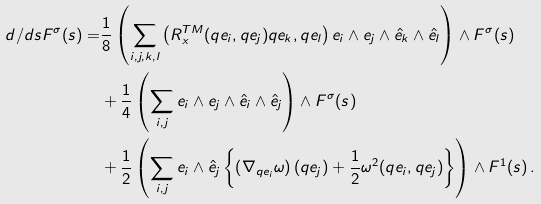<formula> <loc_0><loc_0><loc_500><loc_500>d / d s F ^ { \sigma } ( s ) = & \frac { 1 } { 8 } \left ( \sum _ { i , j , k , l } \left ( R _ { x } ^ { T M } ( q e _ { i } , q e _ { j } ) q e _ { k } , q e _ { l } \right ) e _ { i } \wedge e _ { j } \wedge \hat { e } _ { k } \wedge \hat { e } _ { l } \right ) \wedge F ^ { \sigma } ( s ) \\ & + \frac { 1 } { 4 } \left ( \sum _ { i , j } e _ { i } \wedge e _ { j } \wedge \hat { e } _ { i } \wedge \hat { e } _ { j } \right ) \wedge F ^ { \sigma } ( s ) \\ & + \frac { 1 } { 2 } \left ( \sum _ { i , j } e _ { i } \wedge \hat { e } _ { j } \left \{ \left ( \nabla _ { q e _ { i } } \omega \right ) ( q e _ { j } ) + \frac { 1 } { 2 } \omega ^ { 2 } ( q e _ { i } , q e _ { j } ) \right \} \right ) \wedge F ^ { 1 } ( s ) \, .</formula> 